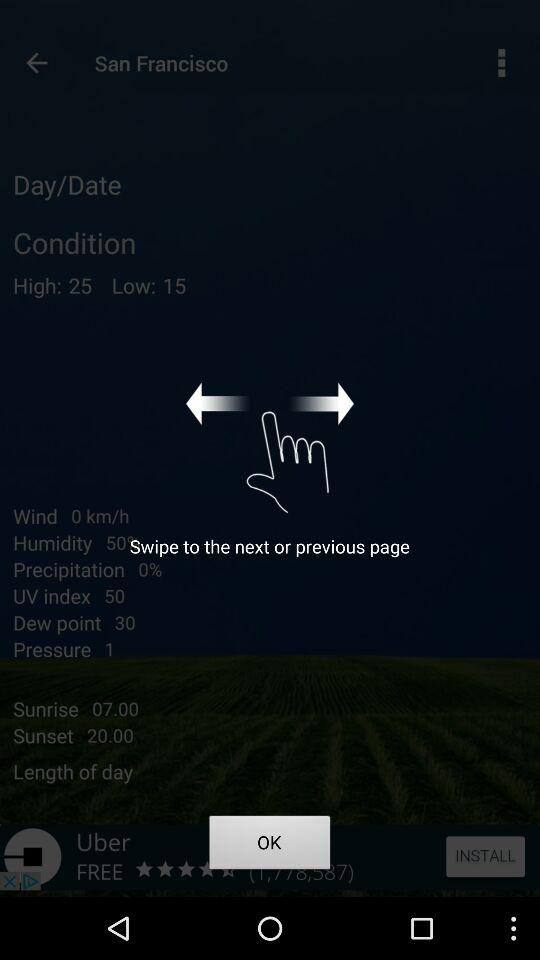What is the difference between the high and low temperatures?
Answer the question using a single word or phrase. 10 